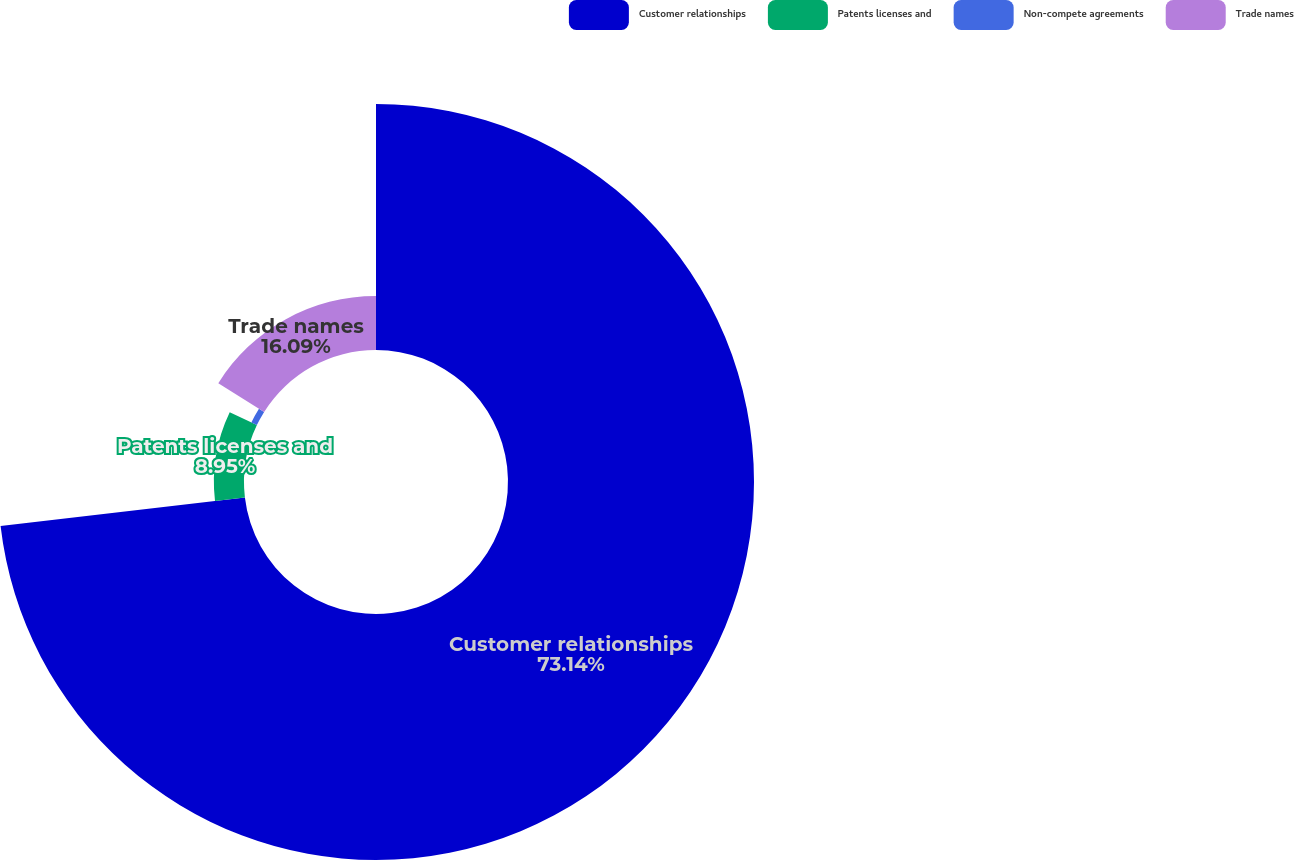Convert chart. <chart><loc_0><loc_0><loc_500><loc_500><pie_chart><fcel>Customer relationships<fcel>Patents licenses and<fcel>Non-compete agreements<fcel>Trade names<nl><fcel>73.14%<fcel>8.95%<fcel>1.82%<fcel>16.09%<nl></chart> 